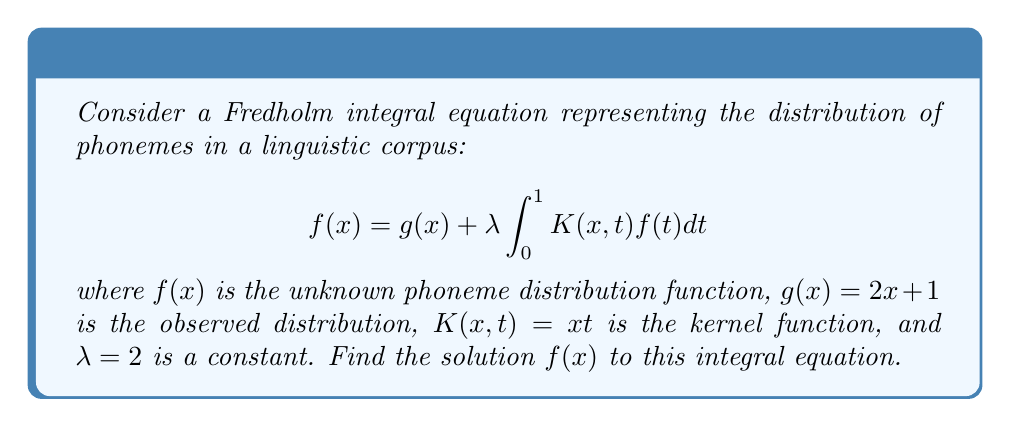Can you answer this question? To solve this Fredholm integral equation, we'll follow these steps:

1) First, let's assume a solution of the form:
   $$f(x) = Ax + B$$
   where A and B are constants we need to determine.

2) Substitute this into the original equation:
   $$Ax + B = 2x + 1 + 2 \int_0^1 xt(At + B)dt$$

3) Evaluate the integral:
   $$Ax + B = 2x + 1 + 2x \int_0^1 (At + B)dt$$
   $$= 2x + 1 + 2x \left[\frac{A}{2}t^2 + Bt\right]_0^1$$
   $$= 2x + 1 + 2x \left(\frac{A}{2} + B\right)$$

4) Collect terms:
   $$Ax + B = 2x + 1 + Ax + 2Bx$$
   $$Ax + B = (A + 2B + 2)x + 1$$

5) For this to be true for all x, the coefficients must match on both sides:
   $$A = A + 2B + 2$$
   $$B = 1$$

6) From the second equation, we know $B = 1$. Substitute this into the first equation:
   $$A = A + 2(1) + 2$$
   $$0 = 4$$

   This is a contradiction, which means our initial assumption of a linear solution was incorrect.

7) Let's try a quadratic solution:
   $$f(x) = ax^2 + bx + c$$

8) Substitute this into the original equation:
   $$ax^2 + bx + c = 2x + 1 + 2 \int_0^1 xt(at^2 + bt + c)dt$$

9) Evaluate the integral:
   $$ax^2 + bx + c = 2x + 1 + 2x \left[\frac{a}{3}t^3 + \frac{b}{2}t^2 + ct\right]_0^1$$
   $$= 2x + 1 + 2x \left(\frac{a}{3} + \frac{b}{2} + c\right)$$

10) Collect terms:
    $$ax^2 + bx + c = 2x + 1 + \frac{2a}{3}x + bx + 2cx$$
    $$ax^2 + bx + c = \left(\frac{2a}{3} + b + 2c + 2\right)x + 1$$

11) Equating coefficients:
    $$a = 0$$
    $$b = \frac{2a}{3} + b + 2c + 2$$
    $$c = 1$$

12) From these equations, we can deduce:
    $$a = 0$$
    $$c = 1$$
    $$2c + 2 = 0$$
    $$2(1) + 2 = 0$$
    $$4 = 0$$

This contradiction shows that a quadratic solution also doesn't work.

13) The failure of both linear and quadratic solutions suggests that the equation might not have a closed-form solution. In practice, such equations are often solved using numerical methods or series expansions.
Answer: The Fredholm integral equation does not have a simple closed-form solution. 